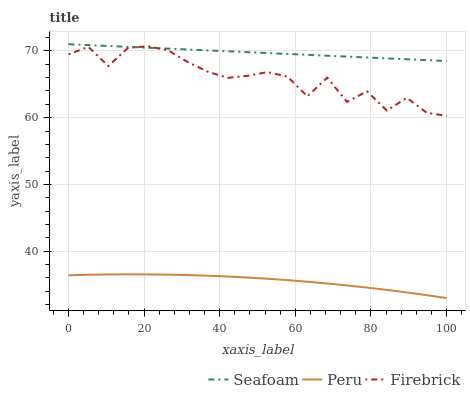Does Peru have the minimum area under the curve?
Answer yes or no. Yes. Does Seafoam have the maximum area under the curve?
Answer yes or no. Yes. Does Seafoam have the minimum area under the curve?
Answer yes or no. No. Does Peru have the maximum area under the curve?
Answer yes or no. No. Is Seafoam the smoothest?
Answer yes or no. Yes. Is Firebrick the roughest?
Answer yes or no. Yes. Is Peru the smoothest?
Answer yes or no. No. Is Peru the roughest?
Answer yes or no. No. Does Peru have the lowest value?
Answer yes or no. Yes. Does Seafoam have the lowest value?
Answer yes or no. No. Does Seafoam have the highest value?
Answer yes or no. Yes. Does Peru have the highest value?
Answer yes or no. No. Is Peru less than Seafoam?
Answer yes or no. Yes. Is Seafoam greater than Peru?
Answer yes or no. Yes. Does Firebrick intersect Seafoam?
Answer yes or no. Yes. Is Firebrick less than Seafoam?
Answer yes or no. No. Is Firebrick greater than Seafoam?
Answer yes or no. No. Does Peru intersect Seafoam?
Answer yes or no. No. 